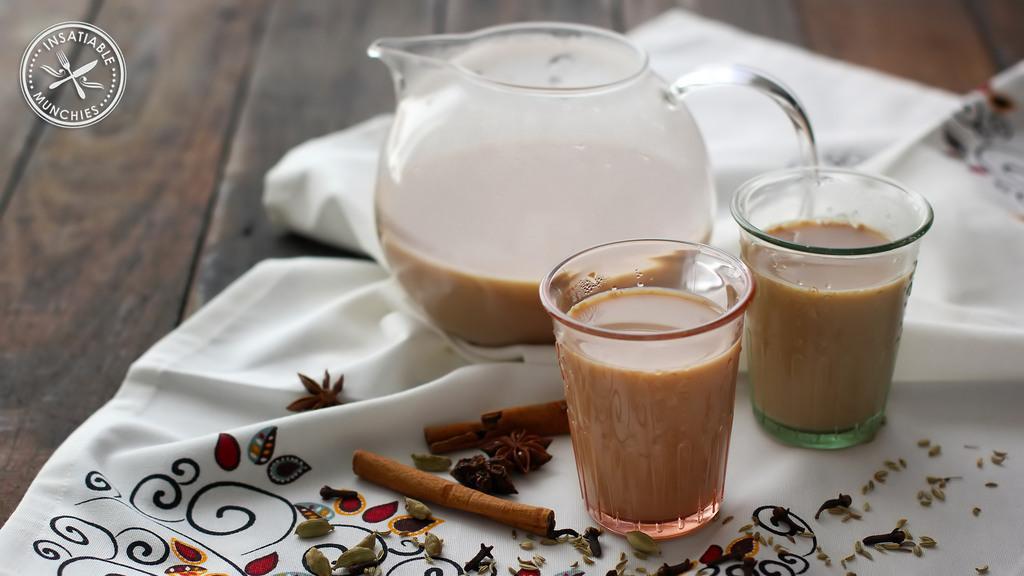Can you describe this image briefly? In this image there is a table having a cloth. Few spices are on the cloth. Right side two glasses and a jar are on the cloth. Two glasses and a jar are filled with the drink. Left top there is a logo. 